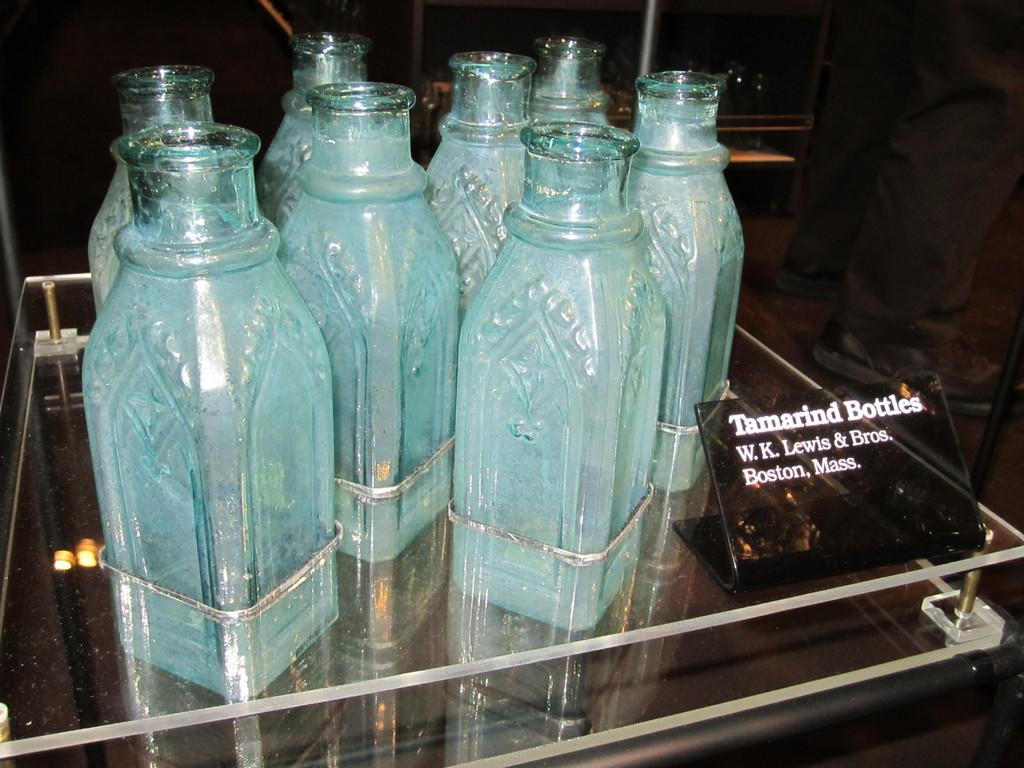<image>
Provide a brief description of the given image. eight bottles sit on display with a sign explaining they are Tamarind Bottles. 